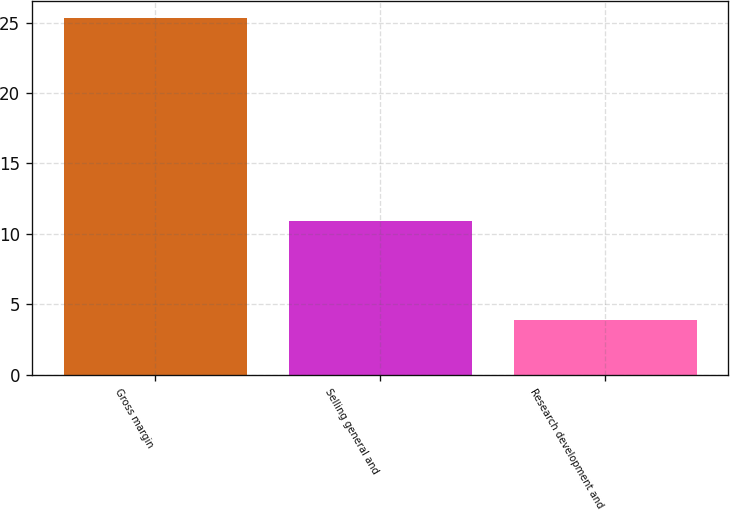Convert chart. <chart><loc_0><loc_0><loc_500><loc_500><bar_chart><fcel>Gross margin<fcel>Selling general and<fcel>Research development and<nl><fcel>25.3<fcel>10.9<fcel>3.9<nl></chart> 